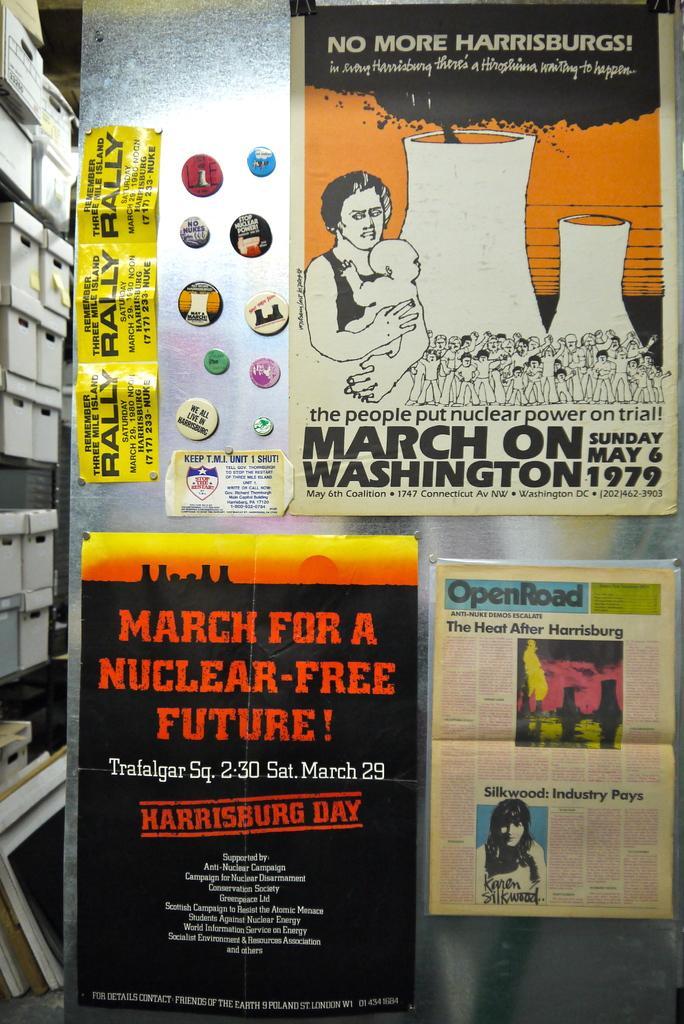How would you summarize this image in a sentence or two? This picture shows few posts on the wall and we see few boxes on the side in the rack. 